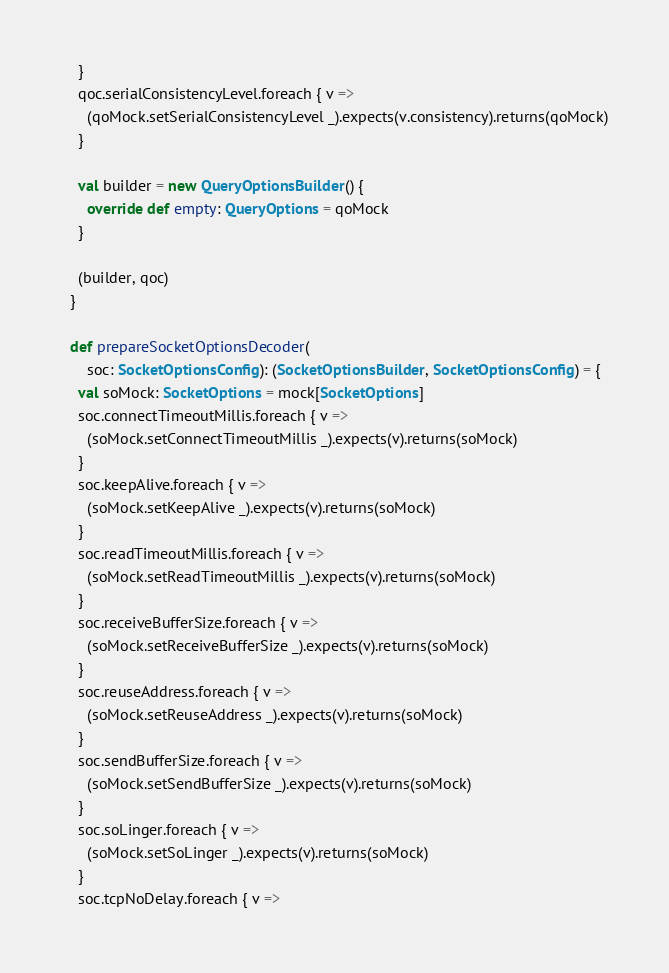<code> <loc_0><loc_0><loc_500><loc_500><_Scala_>    }
    qoc.serialConsistencyLevel.foreach { v =>
      (qoMock.setSerialConsistencyLevel _).expects(v.consistency).returns(qoMock)
    }

    val builder = new QueryOptionsBuilder() {
      override def empty: QueryOptions = qoMock
    }

    (builder, qoc)
  }

  def prepareSocketOptionsDecoder(
      soc: SocketOptionsConfig): (SocketOptionsBuilder, SocketOptionsConfig) = {
    val soMock: SocketOptions = mock[SocketOptions]
    soc.connectTimeoutMillis.foreach { v =>
      (soMock.setConnectTimeoutMillis _).expects(v).returns(soMock)
    }
    soc.keepAlive.foreach { v =>
      (soMock.setKeepAlive _).expects(v).returns(soMock)
    }
    soc.readTimeoutMillis.foreach { v =>
      (soMock.setReadTimeoutMillis _).expects(v).returns(soMock)
    }
    soc.receiveBufferSize.foreach { v =>
      (soMock.setReceiveBufferSize _).expects(v).returns(soMock)
    }
    soc.reuseAddress.foreach { v =>
      (soMock.setReuseAddress _).expects(v).returns(soMock)
    }
    soc.sendBufferSize.foreach { v =>
      (soMock.setSendBufferSize _).expects(v).returns(soMock)
    }
    soc.soLinger.foreach { v =>
      (soMock.setSoLinger _).expects(v).returns(soMock)
    }
    soc.tcpNoDelay.foreach { v =></code> 